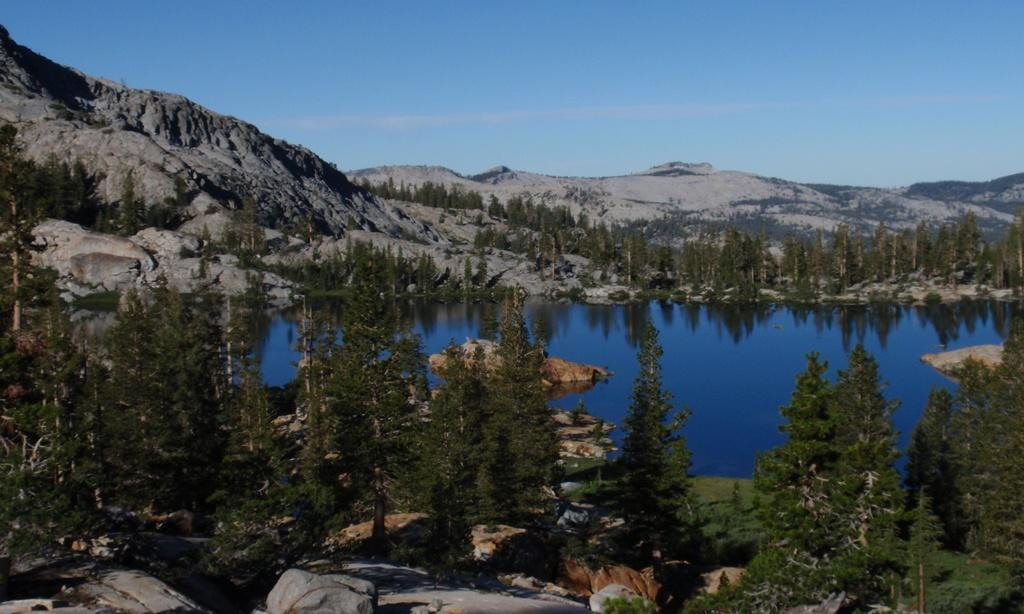What type of location is depicted in the image? The image is an outside view. What natural feature can be seen in the image? There is a sea in the image. What type of vegetation is visible in the image? There are trees visible in the image. What geological features can be seen in the image? There are rocks visible in the image. What type of landscape is visible in the background of the image? There are hills visible in the background of the image. What is visible at the top of the image? The sky is visible at the top of the image. Where is the market located in the image? There is no market present in the image. What type of vest is being worn by the slave in the image? There is no slave or vest present in the image. 